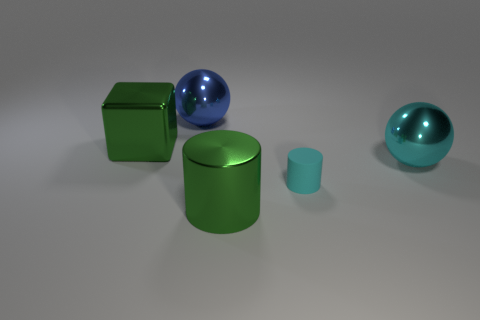Is there anything else that is the same material as the cyan cylinder?
Ensure brevity in your answer.  No. There is a cyan matte object; what number of tiny cyan cylinders are behind it?
Ensure brevity in your answer.  0. There is a large green thing behind the cyan metal ball; is it the same shape as the big cyan shiny object?
Provide a succinct answer. No. There is a big object that is behind the large green cube; what is its color?
Keep it short and to the point. Blue. There is a large blue object that is made of the same material as the large cyan ball; what shape is it?
Keep it short and to the point. Sphere. Is there anything else of the same color as the block?
Your response must be concise. Yes. Is the number of big green metal things left of the big cube greater than the number of small rubber cylinders in front of the cyan shiny ball?
Ensure brevity in your answer.  No. How many cyan matte things have the same size as the cyan metallic object?
Provide a succinct answer. 0. Is the number of cyan matte things that are on the left side of the green cylinder less than the number of big blue things that are in front of the big blue ball?
Your response must be concise. No. Is there a big green thing of the same shape as the cyan rubber thing?
Offer a terse response. Yes. 